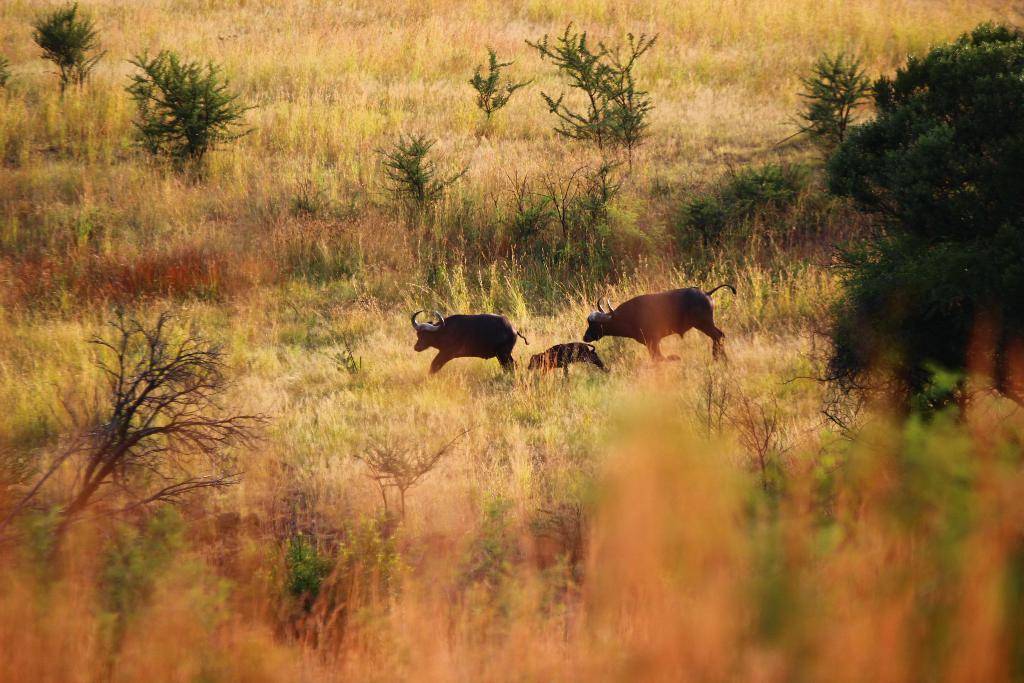What animals are present in the image? There are buffaloes in the image. What are the buffaloes doing in the image? The buffaloes are running on the ground. What type of vegetation can be seen in the image? There are plants, grass, and a tree in the image. What type of cloth is being used to make the buffaloes' journey more comfortable in the image? There is no cloth present in the image, nor is there any indication that the buffaloes are on a journey. 